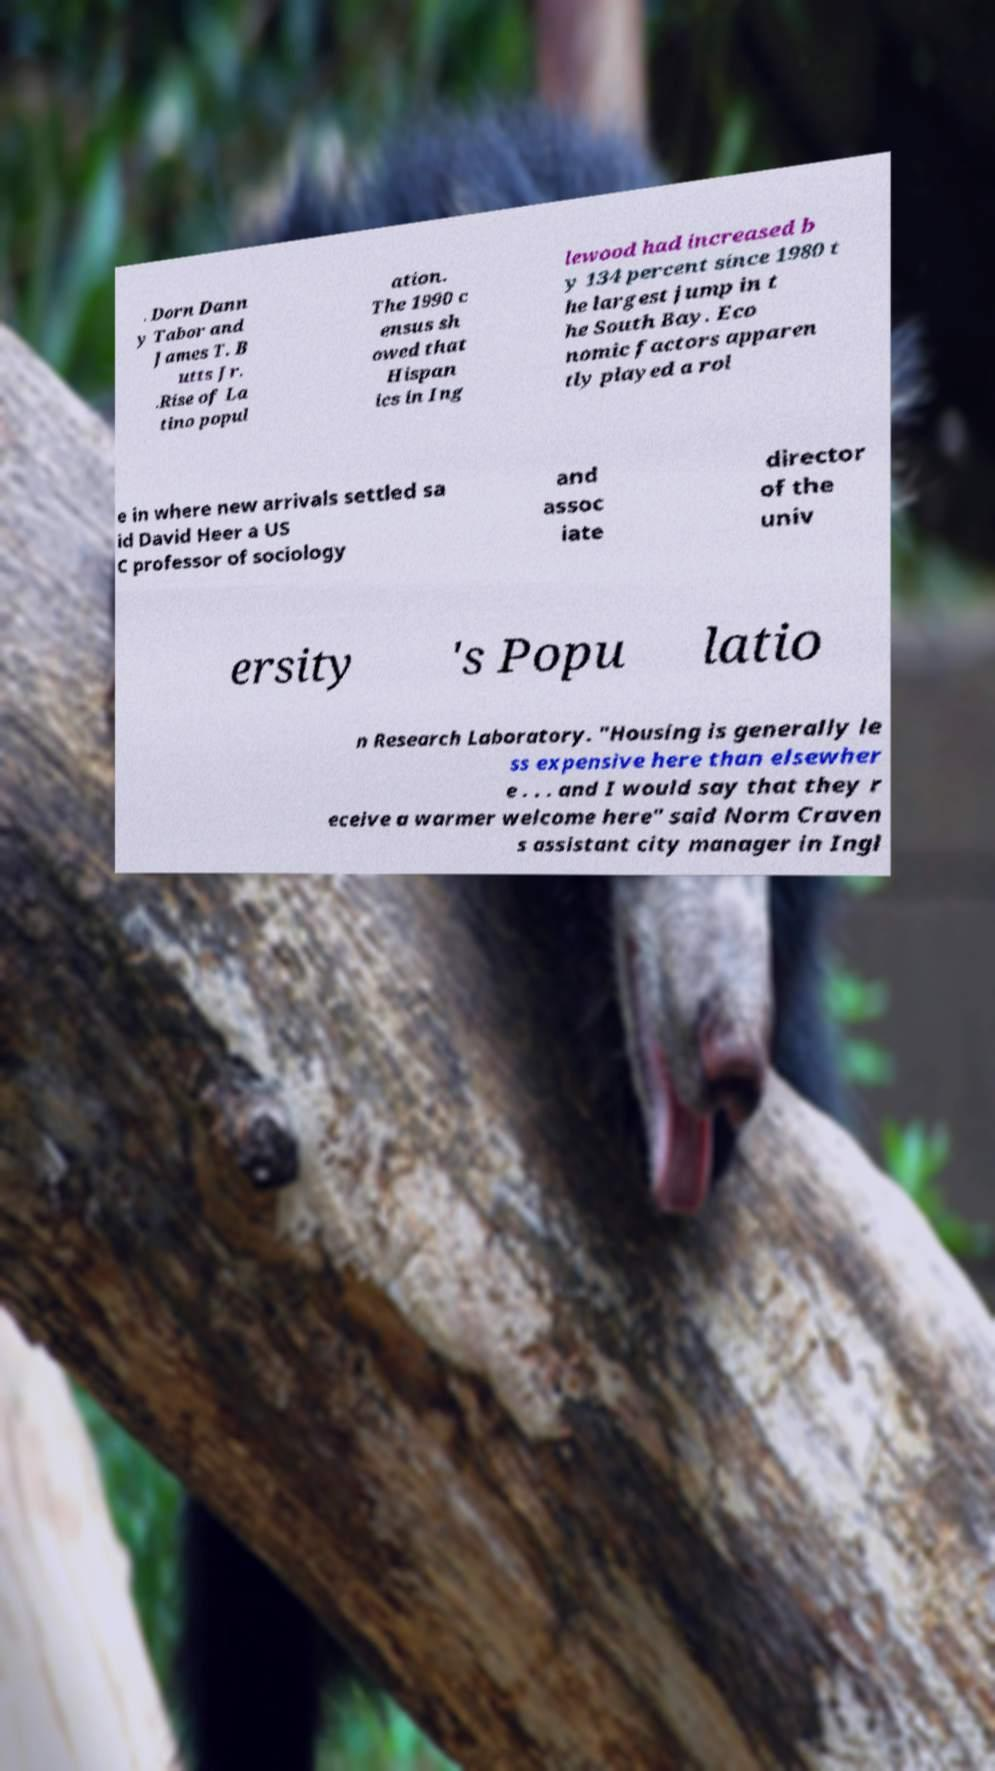Please identify and transcribe the text found in this image. . Dorn Dann y Tabor and James T. B utts Jr. .Rise of La tino popul ation. The 1990 c ensus sh owed that Hispan ics in Ing lewood had increased b y 134 percent since 1980 t he largest jump in t he South Bay. Eco nomic factors apparen tly played a rol e in where new arrivals settled sa id David Heer a US C professor of sociology and assoc iate director of the univ ersity 's Popu latio n Research Laboratory. "Housing is generally le ss expensive here than elsewher e . . . and I would say that they r eceive a warmer welcome here" said Norm Craven s assistant city manager in Ingl 